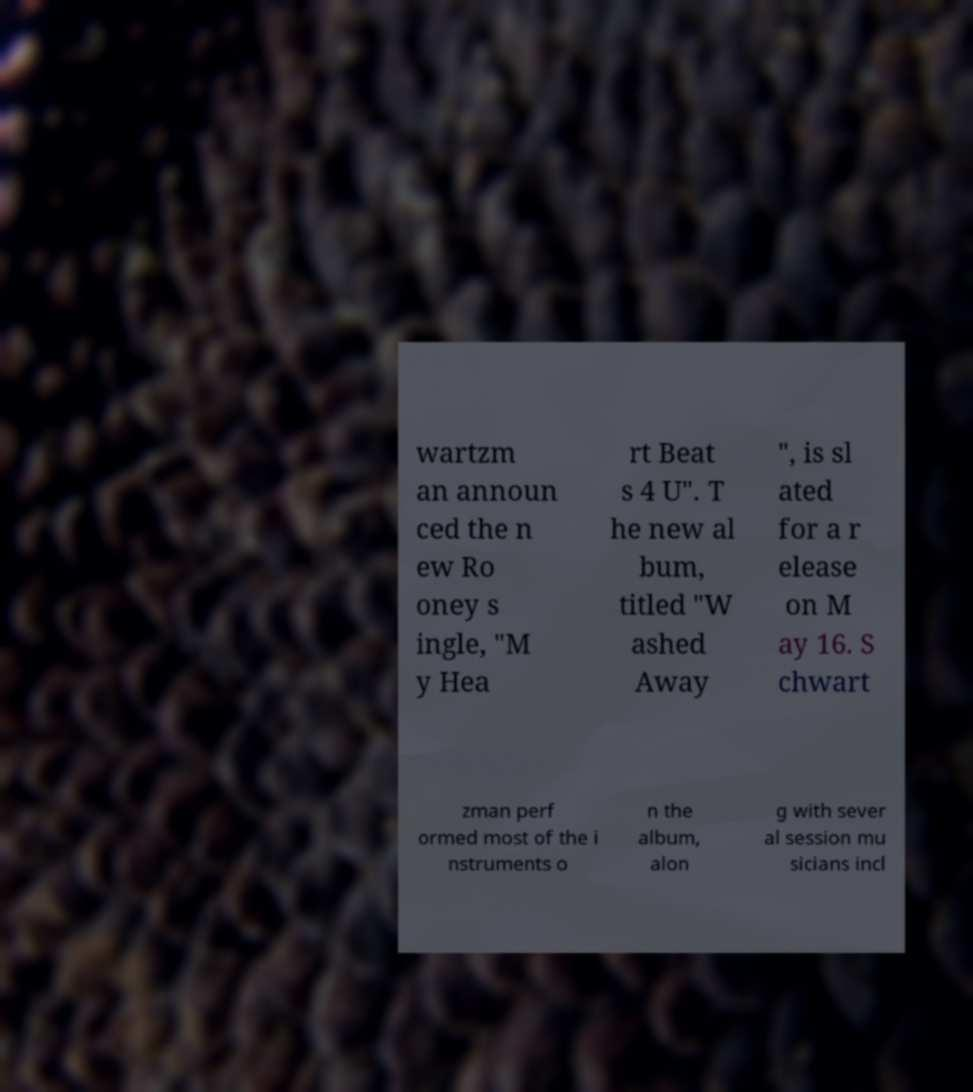For documentation purposes, I need the text within this image transcribed. Could you provide that? wartzm an announ ced the n ew Ro oney s ingle, "M y Hea rt Beat s 4 U". T he new al bum, titled "W ashed Away ", is sl ated for a r elease on M ay 16. S chwart zman perf ormed most of the i nstruments o n the album, alon g with sever al session mu sicians incl 